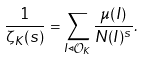Convert formula to latex. <formula><loc_0><loc_0><loc_500><loc_500>\frac { 1 } { \zeta _ { K } ( s ) } = \sum _ { I \triangleleft \mathcal { O } _ { K } } \frac { \mu ( I ) } { N ( I ) ^ { s } } .</formula> 